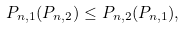<formula> <loc_0><loc_0><loc_500><loc_500>P _ { n , 1 } ( { P } _ { n , 2 } ) \leq P _ { n , 2 } ( { P } _ { n , 1 } ) ,</formula> 